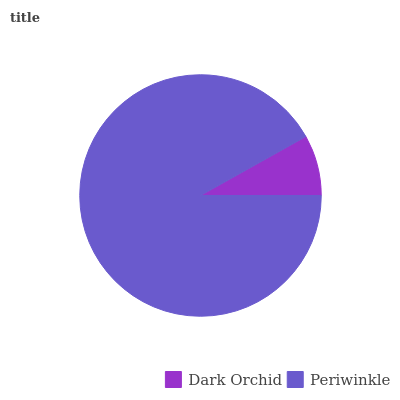Is Dark Orchid the minimum?
Answer yes or no. Yes. Is Periwinkle the maximum?
Answer yes or no. Yes. Is Periwinkle the minimum?
Answer yes or no. No. Is Periwinkle greater than Dark Orchid?
Answer yes or no. Yes. Is Dark Orchid less than Periwinkle?
Answer yes or no. Yes. Is Dark Orchid greater than Periwinkle?
Answer yes or no. No. Is Periwinkle less than Dark Orchid?
Answer yes or no. No. Is Periwinkle the high median?
Answer yes or no. Yes. Is Dark Orchid the low median?
Answer yes or no. Yes. Is Dark Orchid the high median?
Answer yes or no. No. Is Periwinkle the low median?
Answer yes or no. No. 